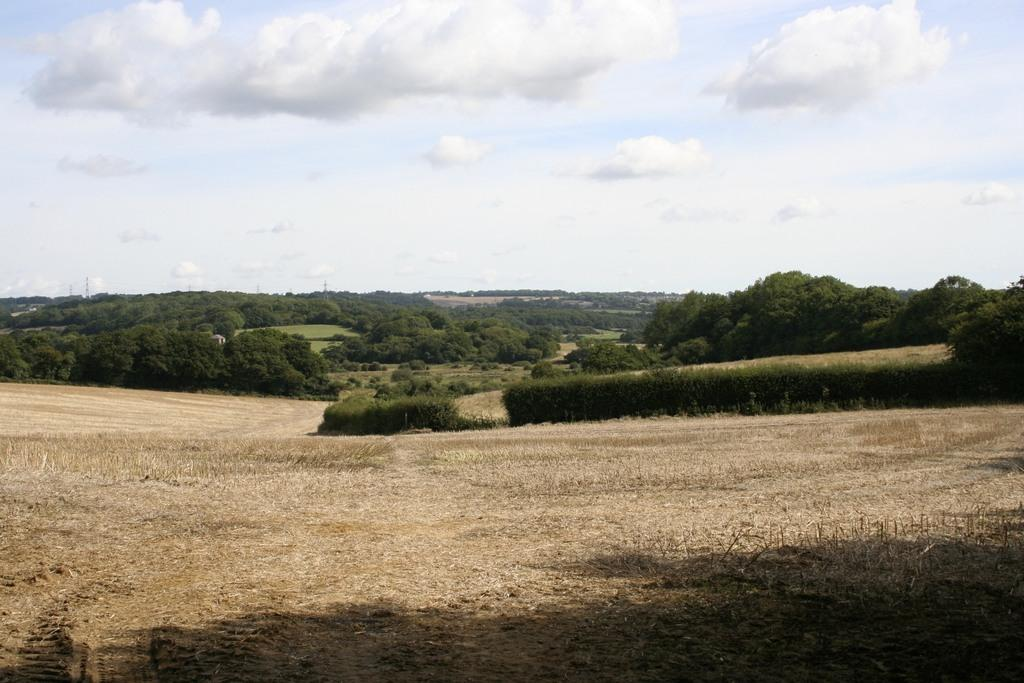What type of vegetation can be seen in the image? There are trees in the image. What type of terrain is visible in the image? There is land visible in the image. What is the condition of the sky in the image? The sky is cloudy in the image. What type of payment method is accepted by the monkey in the image? There is no monkey present in the image, so no payment method can be accepted. 